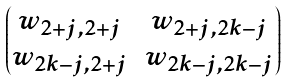Convert formula to latex. <formula><loc_0><loc_0><loc_500><loc_500>\begin{pmatrix} w _ { 2 + j , 2 + j } & w _ { 2 + j , 2 k - j } \\ w _ { 2 k - j , 2 + j } & w _ { 2 k - j , 2 k - j } \end{pmatrix}</formula> 